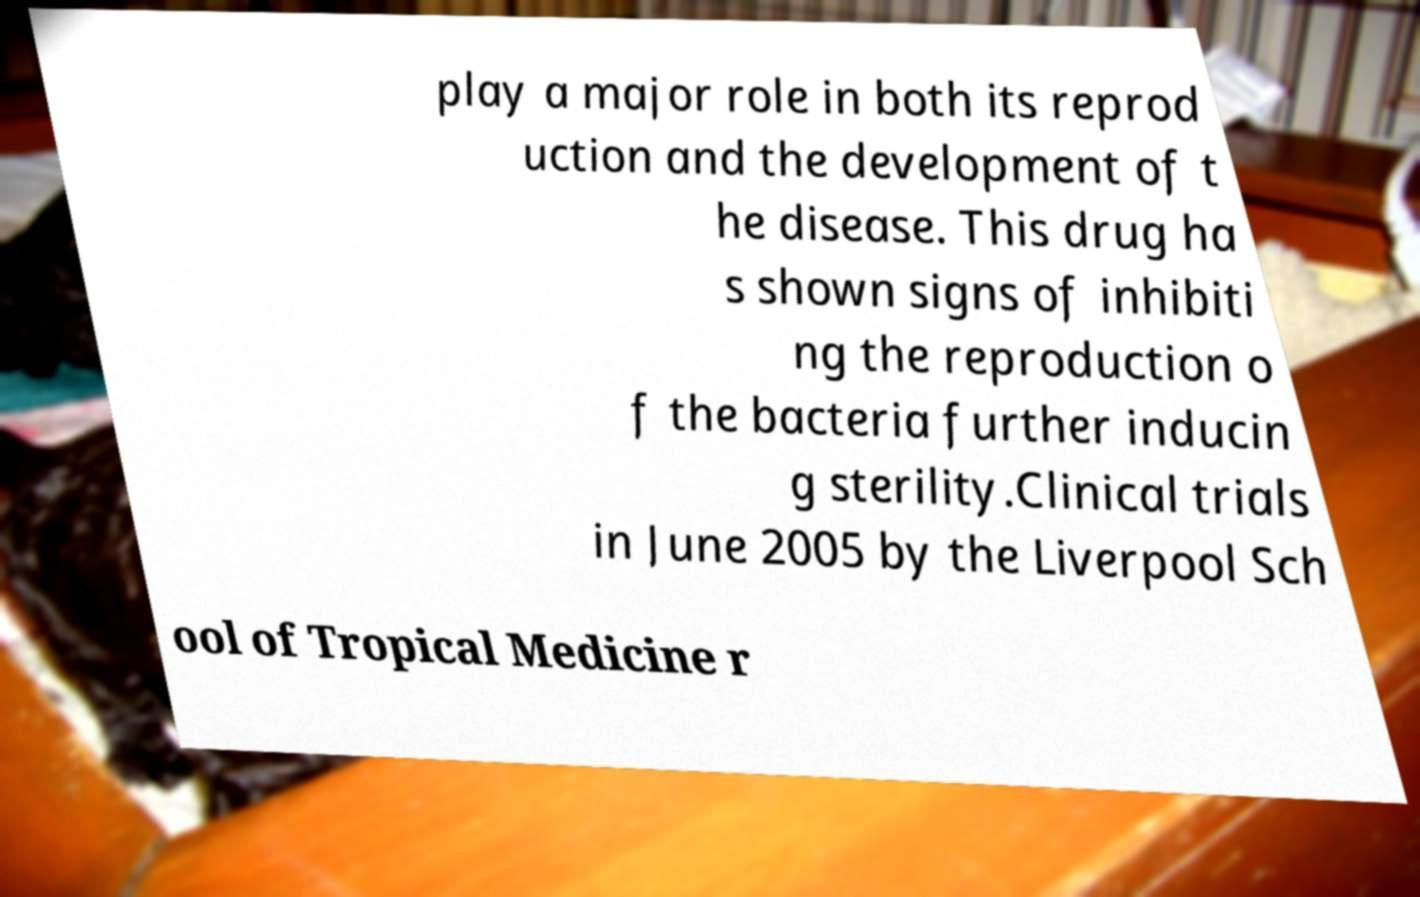I need the written content from this picture converted into text. Can you do that? play a major role in both its reprod uction and the development of t he disease. This drug ha s shown signs of inhibiti ng the reproduction o f the bacteria further inducin g sterility.Clinical trials in June 2005 by the Liverpool Sch ool of Tropical Medicine r 